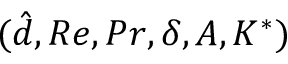<formula> <loc_0><loc_0><loc_500><loc_500>( \hat { d } , R e , P r , \delta , A , K ^ { * } )</formula> 